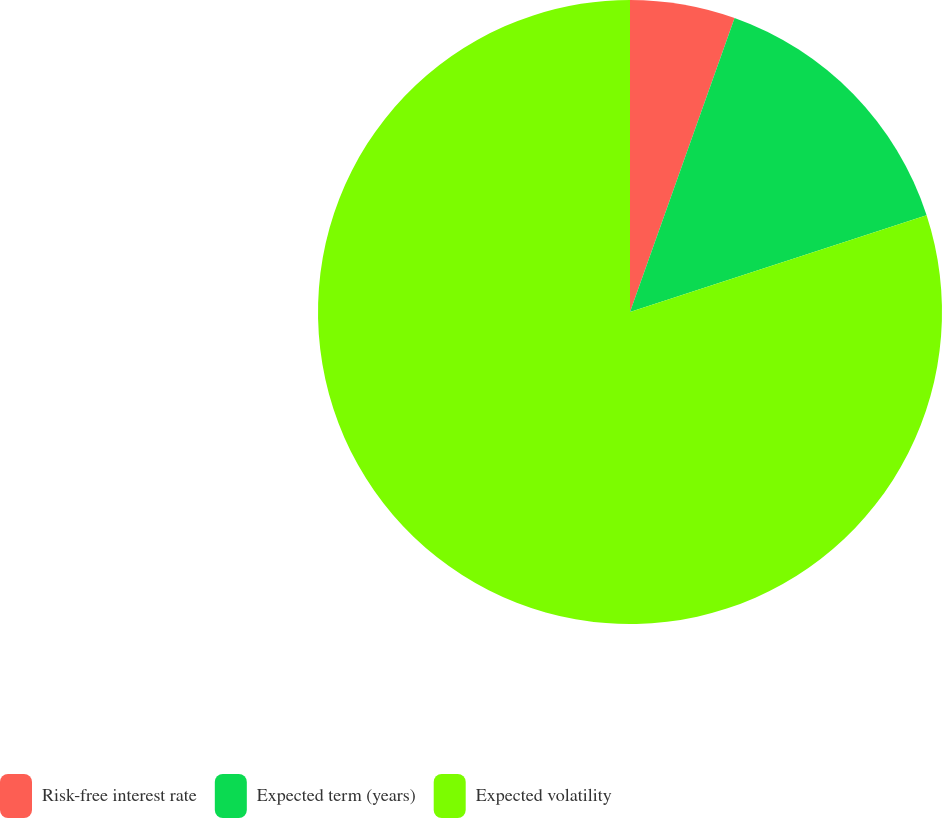Convert chart. <chart><loc_0><loc_0><loc_500><loc_500><pie_chart><fcel>Risk-free interest rate<fcel>Expected term (years)<fcel>Expected volatility<nl><fcel>5.44%<fcel>14.54%<fcel>80.02%<nl></chart> 